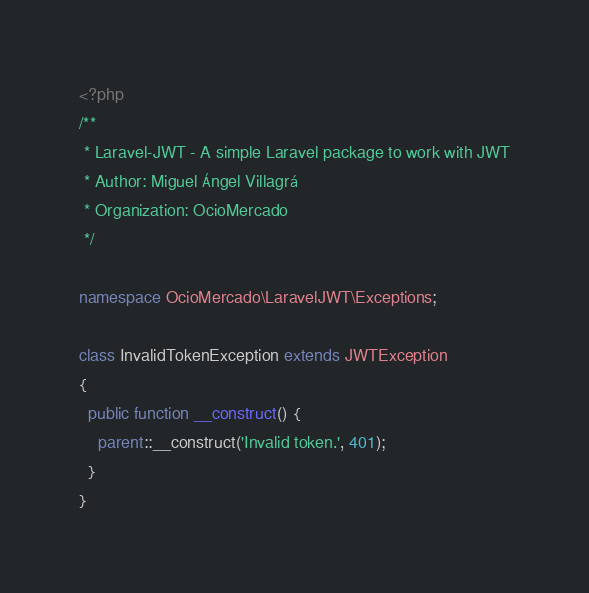<code> <loc_0><loc_0><loc_500><loc_500><_PHP_><?php
/**
 * Laravel-JWT - A simple Laravel package to work with JWT
 * Author: Miguel Ángel Villagrá
 * Organization: OcioMercado
 */

namespace OcioMercado\LaravelJWT\Exceptions;

class InvalidTokenException extends JWTException
{
  public function __construct() {
    parent::__construct('Invalid token.', 401);
  }
}</code> 